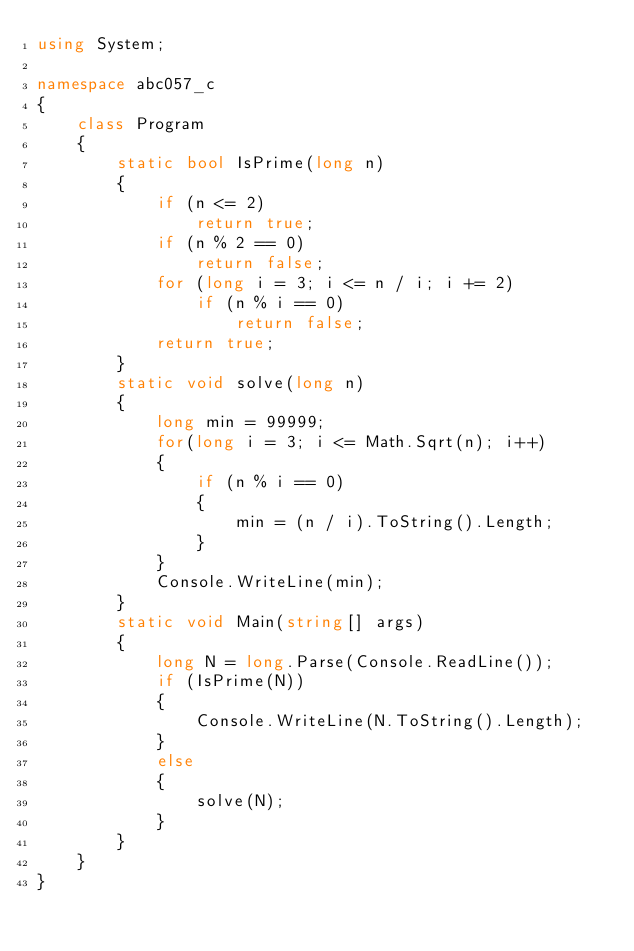Convert code to text. <code><loc_0><loc_0><loc_500><loc_500><_C#_>using System;

namespace abc057_c
{
    class Program
    {
        static bool IsPrime(long n)
        {
            if (n <= 2)
                return true;
            if (n % 2 == 0)
                return false;
            for (long i = 3; i <= n / i; i += 2)
                if (n % i == 0)
                    return false;
            return true;
        }
        static void solve(long n)
        {
            long min = 99999;
            for(long i = 3; i <= Math.Sqrt(n); i++)
            {
                if (n % i == 0)
                {
                    min = (n / i).ToString().Length;
                }
            }
            Console.WriteLine(min);
        }
        static void Main(string[] args)
        {
            long N = long.Parse(Console.ReadLine());
            if (IsPrime(N))
            {
                Console.WriteLine(N.ToString().Length);
            }
            else
            {
                solve(N);
            }
        }
    }
}
</code> 